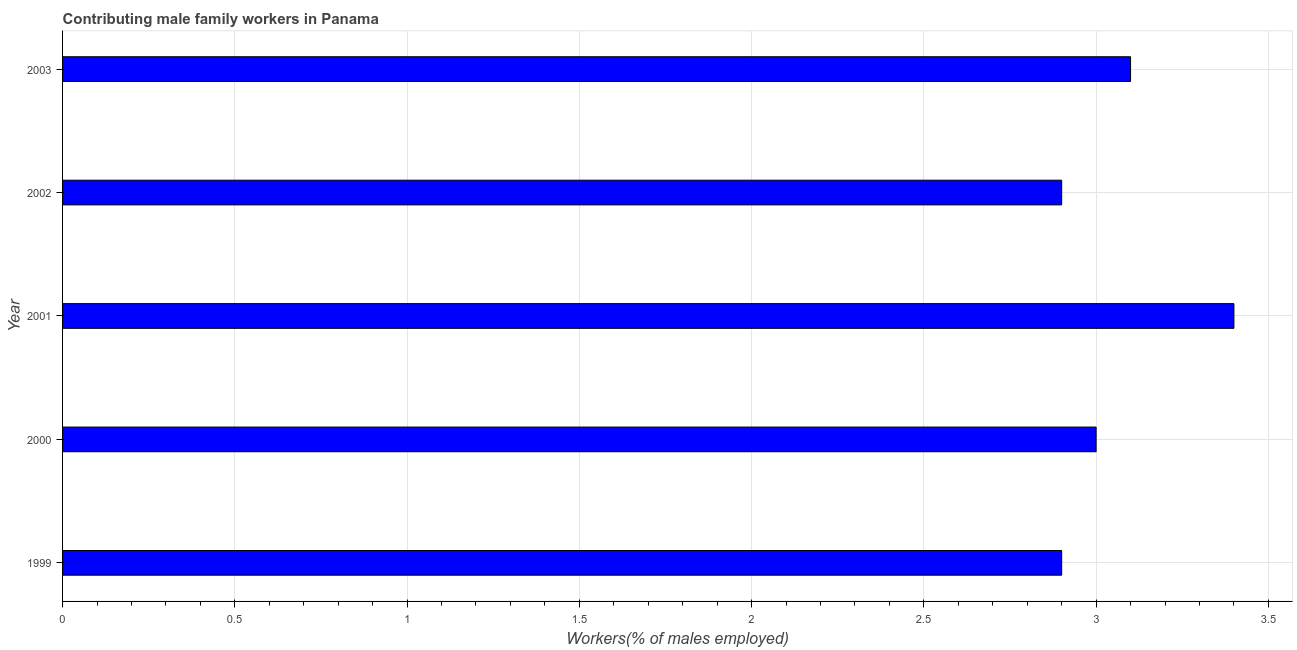Does the graph contain grids?
Give a very brief answer. Yes. What is the title of the graph?
Make the answer very short. Contributing male family workers in Panama. What is the label or title of the X-axis?
Ensure brevity in your answer.  Workers(% of males employed). What is the label or title of the Y-axis?
Provide a succinct answer. Year. What is the contributing male family workers in 2001?
Keep it short and to the point. 3.4. Across all years, what is the maximum contributing male family workers?
Give a very brief answer. 3.4. Across all years, what is the minimum contributing male family workers?
Give a very brief answer. 2.9. In which year was the contributing male family workers maximum?
Ensure brevity in your answer.  2001. What is the sum of the contributing male family workers?
Keep it short and to the point. 15.3. What is the difference between the contributing male family workers in 1999 and 2003?
Your answer should be very brief. -0.2. What is the average contributing male family workers per year?
Give a very brief answer. 3.06. What is the median contributing male family workers?
Provide a succinct answer. 3. In how many years, is the contributing male family workers greater than 0.4 %?
Your answer should be very brief. 5. What is the ratio of the contributing male family workers in 2001 to that in 2002?
Your response must be concise. 1.17. What is the difference between the highest and the second highest contributing male family workers?
Give a very brief answer. 0.3. Is the sum of the contributing male family workers in 2000 and 2002 greater than the maximum contributing male family workers across all years?
Keep it short and to the point. Yes. How many bars are there?
Ensure brevity in your answer.  5. How many years are there in the graph?
Your answer should be compact. 5. What is the Workers(% of males employed) in 1999?
Provide a short and direct response. 2.9. What is the Workers(% of males employed) in 2001?
Provide a succinct answer. 3.4. What is the Workers(% of males employed) in 2002?
Ensure brevity in your answer.  2.9. What is the Workers(% of males employed) of 2003?
Offer a terse response. 3.1. What is the difference between the Workers(% of males employed) in 1999 and 2002?
Provide a succinct answer. 0. What is the difference between the Workers(% of males employed) in 2000 and 2001?
Provide a short and direct response. -0.4. What is the difference between the Workers(% of males employed) in 2000 and 2002?
Ensure brevity in your answer.  0.1. What is the ratio of the Workers(% of males employed) in 1999 to that in 2001?
Give a very brief answer. 0.85. What is the ratio of the Workers(% of males employed) in 1999 to that in 2002?
Make the answer very short. 1. What is the ratio of the Workers(% of males employed) in 1999 to that in 2003?
Make the answer very short. 0.94. What is the ratio of the Workers(% of males employed) in 2000 to that in 2001?
Provide a short and direct response. 0.88. What is the ratio of the Workers(% of males employed) in 2000 to that in 2002?
Provide a short and direct response. 1.03. What is the ratio of the Workers(% of males employed) in 2001 to that in 2002?
Provide a succinct answer. 1.17. What is the ratio of the Workers(% of males employed) in 2001 to that in 2003?
Provide a short and direct response. 1.1. What is the ratio of the Workers(% of males employed) in 2002 to that in 2003?
Your response must be concise. 0.94. 